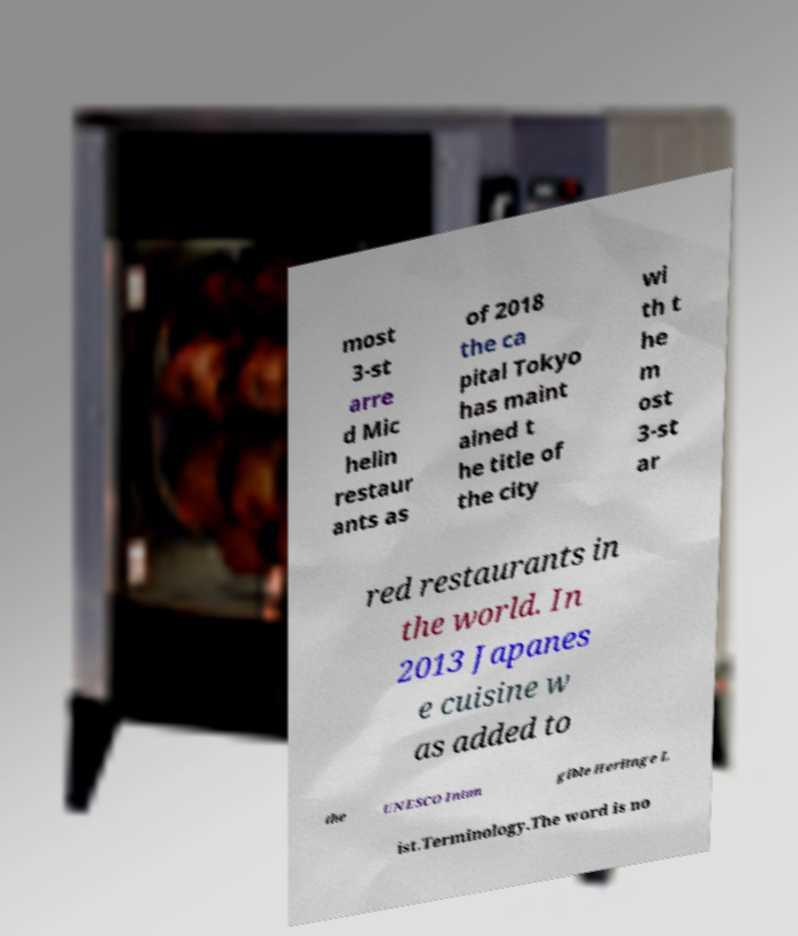Can you read and provide the text displayed in the image?This photo seems to have some interesting text. Can you extract and type it out for me? most 3-st arre d Mic helin restaur ants as of 2018 the ca pital Tokyo has maint ained t he title of the city wi th t he m ost 3-st ar red restaurants in the world. In 2013 Japanes e cuisine w as added to the UNESCO Intan gible Heritage L ist.Terminology.The word is no 